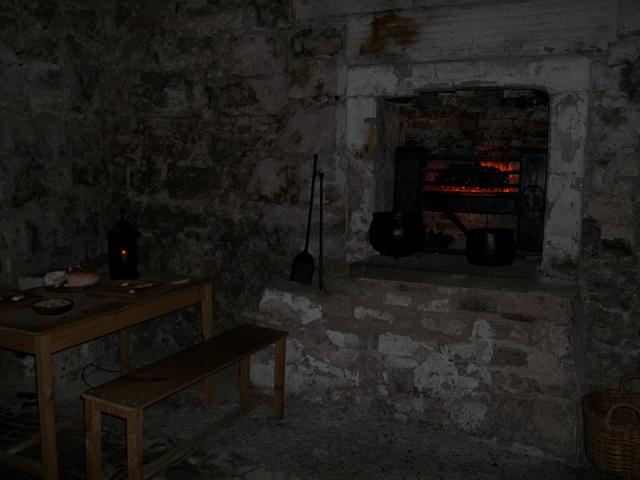Are those the original bricks on the wall?
Write a very short answer. Yes. Is this in a third world country?
Quick response, please. No. What kind of oven is this?
Write a very short answer. Brick. Is the fireplace lit?
Give a very brief answer. Yes. Is this a patio?
Keep it brief. No. Is this taken outdoor?
Answer briefly. No. Where is this?
Be succinct. Kitchen. Is it evening?
Keep it brief. Yes. Is the fire burning?
Short answer required. Yes. Is this a modern home?
Short answer required. No. What is inside the wall in the background?
Answer briefly. Fireplace. Where is the chimney?
Quick response, please. Above fireplace. Where is the bench?
Answer briefly. By table. Is it daytime?
Write a very short answer. No. What surrounds the patio?
Keep it brief. Stone. What kind of film was used to take this picture?
Concise answer only. 35mm. What is on fire?
Keep it brief. Wood. What is the wall made of?
Concise answer only. Brick. 